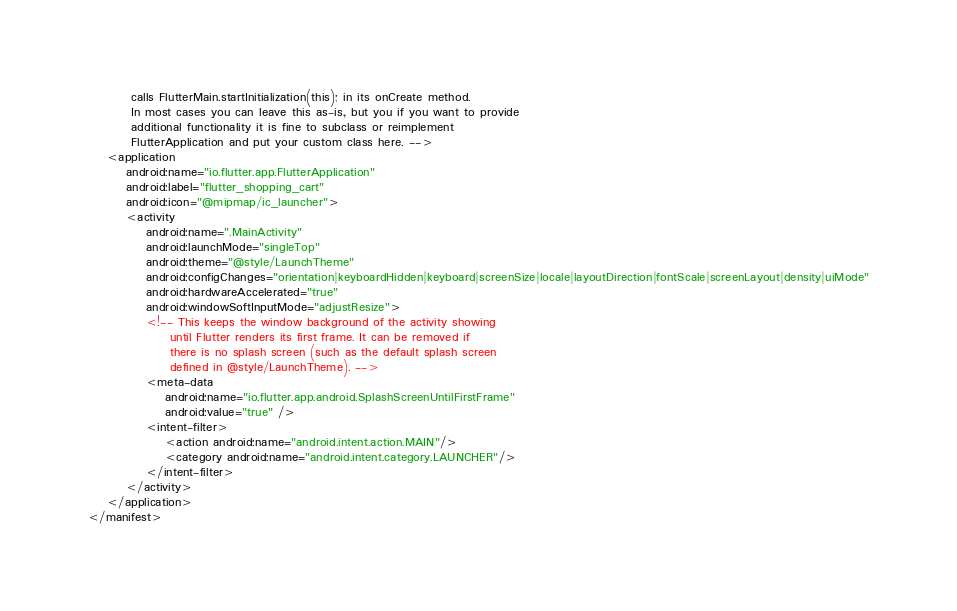Convert code to text. <code><loc_0><loc_0><loc_500><loc_500><_XML_>         calls FlutterMain.startInitialization(this); in its onCreate method.
         In most cases you can leave this as-is, but you if you want to provide
         additional functionality it is fine to subclass or reimplement
         FlutterApplication and put your custom class here. -->
    <application
        android:name="io.flutter.app.FlutterApplication"
        android:label="flutter_shopping_cart"
        android:icon="@mipmap/ic_launcher">
        <activity
            android:name=".MainActivity"
            android:launchMode="singleTop"
            android:theme="@style/LaunchTheme"
            android:configChanges="orientation|keyboardHidden|keyboard|screenSize|locale|layoutDirection|fontScale|screenLayout|density|uiMode"
            android:hardwareAccelerated="true"
            android:windowSoftInputMode="adjustResize">
            <!-- This keeps the window background of the activity showing
                 until Flutter renders its first frame. It can be removed if
                 there is no splash screen (such as the default splash screen
                 defined in @style/LaunchTheme). -->
            <meta-data
                android:name="io.flutter.app.android.SplashScreenUntilFirstFrame"
                android:value="true" />
            <intent-filter>
                <action android:name="android.intent.action.MAIN"/>
                <category android:name="android.intent.category.LAUNCHER"/>
            </intent-filter>
        </activity>
    </application>
</manifest>
</code> 